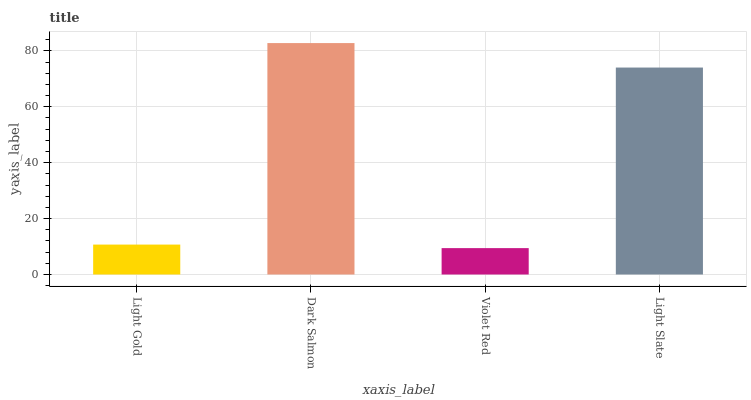Is Dark Salmon the minimum?
Answer yes or no. No. Is Violet Red the maximum?
Answer yes or no. No. Is Dark Salmon greater than Violet Red?
Answer yes or no. Yes. Is Violet Red less than Dark Salmon?
Answer yes or no. Yes. Is Violet Red greater than Dark Salmon?
Answer yes or no. No. Is Dark Salmon less than Violet Red?
Answer yes or no. No. Is Light Slate the high median?
Answer yes or no. Yes. Is Light Gold the low median?
Answer yes or no. Yes. Is Violet Red the high median?
Answer yes or no. No. Is Violet Red the low median?
Answer yes or no. No. 